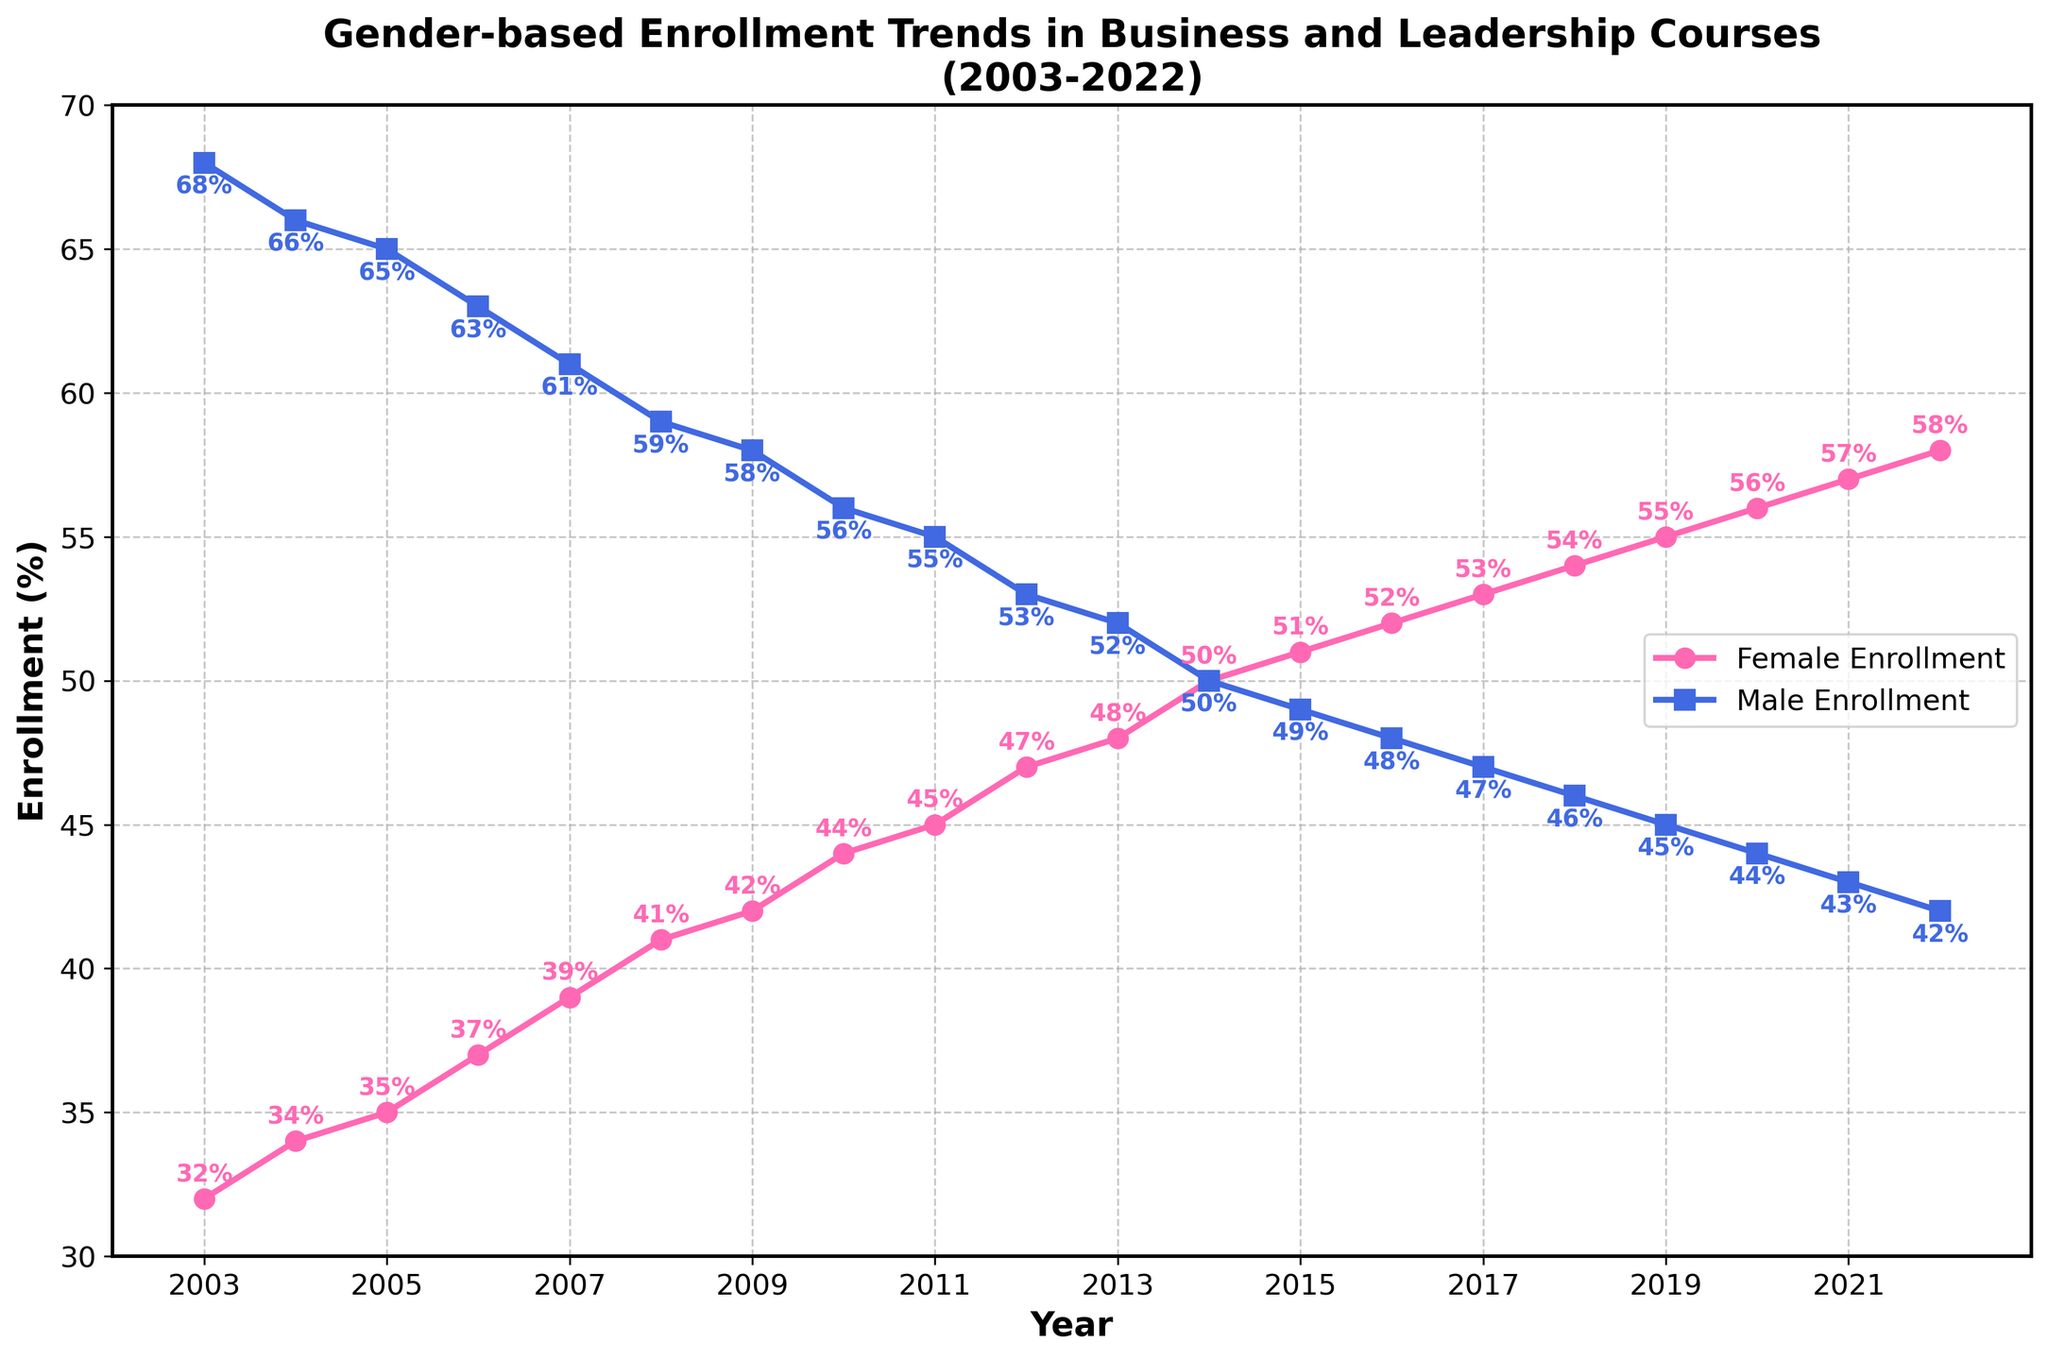What was the trend in female enrollment from 2003 to 2022? The figure shows that female enrollment steadily increased each year from 32% in 2003 to 58% in 2022. This upward trend indicates a growing interest among women in business and leadership courses over the years.
Answer: It steadily increased How did male enrollment change from 2003 to 2022? Male enrollment shows a steady decline from 68% in 2003 to 42% in 2022. This suggests a gradual decrease in male participation in business and leadership courses over the two decades.
Answer: It steadily decreased In which year did female enrollment surpass male enrollment? Observing the figure, female enrollment surpassed male enrollment in 2014, where both genders hit the 50% mark, and thereafter, female enrollment continued to rise above 50%.
Answer: 2014 What was the difference in female and male enrollment in 2011? Female enrollment in 2011 was 45%, and male enrollment was 55%. The difference between them is 55% - 45% = 10%.
Answer: 10% In 2020, what can you say about the gender balance in enrollment? In 2020, female enrollment was 56%, and male enrollment was 44%. This shows that more females were enrolled than males during that year.
Answer: More females were enrolled How much did female enrollment increase from 2003 to 2022? Female enrollment in 2003 was 32%, and in 2022 it was 58%. The increase is calculated as 58% - 32% = 26%.
Answer: 26% Did male enrollment ever increase from one year to the next? No, the male enrollment steadily decreases every year. The trend does not show any increase in male enrollment over the two decades.
Answer: No What was the average female enrollment from 2010 to 2020? To find the average, add the female enrollment percentages from 2010 to 2020 and divide by the number of years: (44 + 45 + 47 + 48 + 50 + 51 + 52 + 53 + 54 + 55 + 56) = 555, then 555 / 11 = 50.45%.
Answer: 50.45% Compare the trends in male and female enrollment from 2014 to 2022. From 2014 to 2022, female enrollment rose from 50% to 58%, showing an upward trend. In contrast, male enrollment decreased from 50% to 42%, indicating a downward trend. This period highlights a diverging trend between male and female enrollment.
Answer: Diverging trends What was the enrollment ratio of males to females in 2006? In 2006, female enrollment was 37%, and male enrollment was 63%. The ratio of males to females is 63:37.
Answer: 63:37 